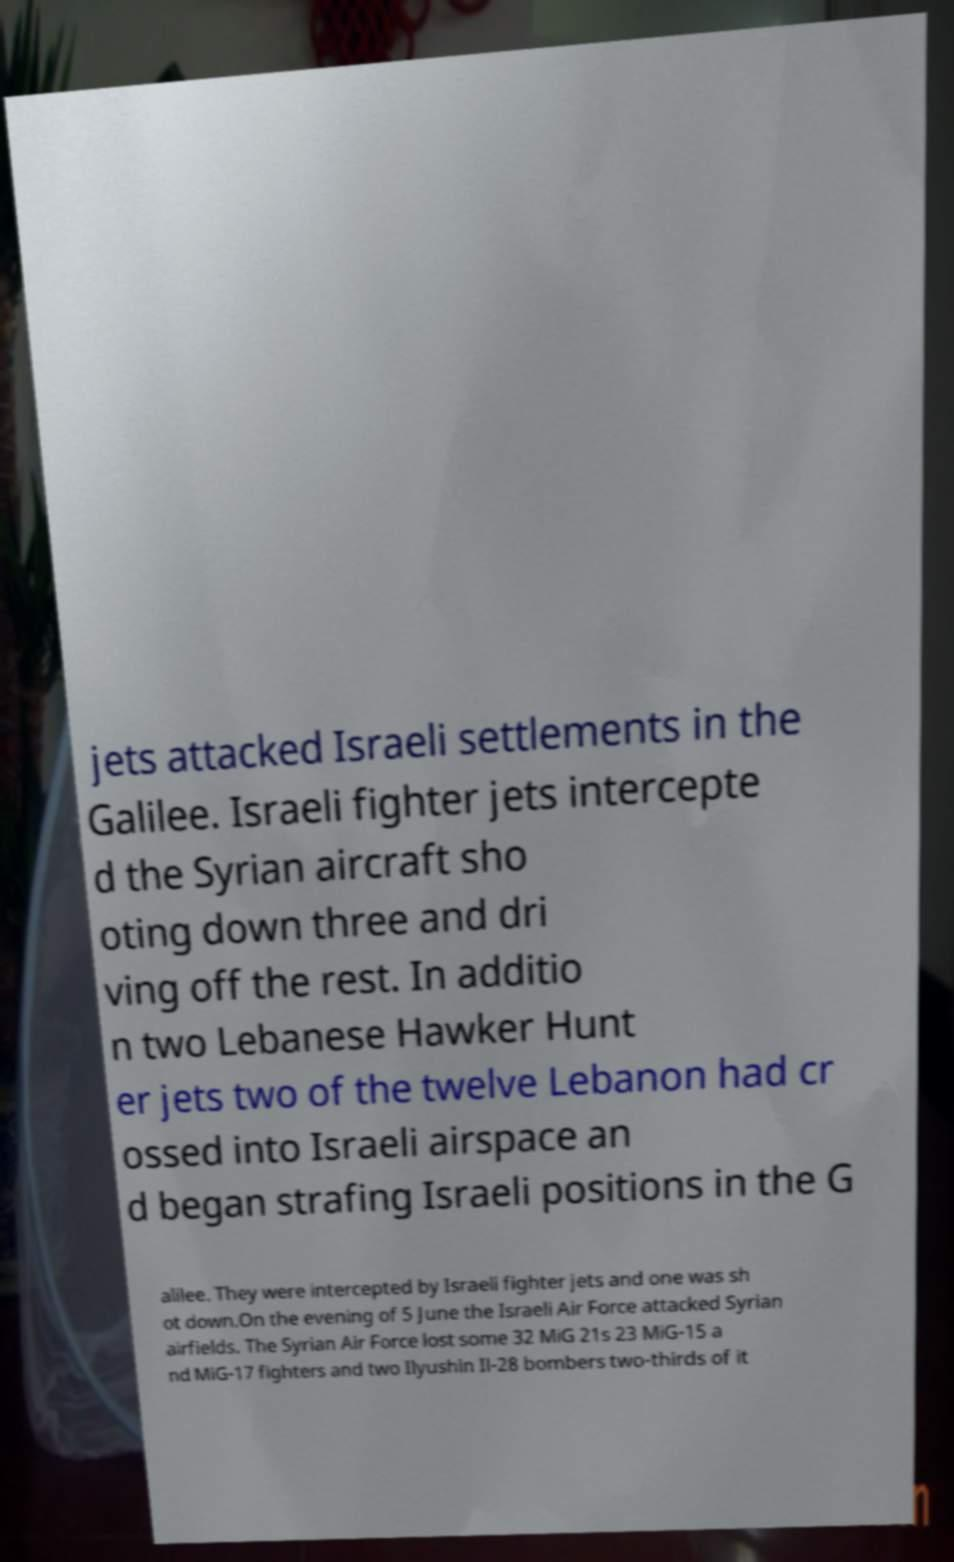What messages or text are displayed in this image? I need them in a readable, typed format. jets attacked Israeli settlements in the Galilee. Israeli fighter jets intercepte d the Syrian aircraft sho oting down three and dri ving off the rest. In additio n two Lebanese Hawker Hunt er jets two of the twelve Lebanon had cr ossed into Israeli airspace an d began strafing Israeli positions in the G alilee. They were intercepted by Israeli fighter jets and one was sh ot down.On the evening of 5 June the Israeli Air Force attacked Syrian airfields. The Syrian Air Force lost some 32 MiG 21s 23 MiG-15 a nd MiG-17 fighters and two Ilyushin Il-28 bombers two-thirds of it 